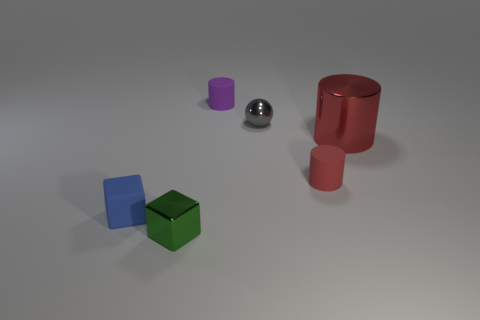Subtract all small matte cylinders. How many cylinders are left? 1 Subtract all brown spheres. How many red cylinders are left? 2 Add 2 shiny cylinders. How many objects exist? 8 Subtract all green cylinders. Subtract all gray spheres. How many cylinders are left? 3 Subtract 1 blue cubes. How many objects are left? 5 Subtract all cubes. How many objects are left? 4 Subtract all tiny gray matte things. Subtract all small red objects. How many objects are left? 5 Add 2 tiny red matte cylinders. How many tiny red matte cylinders are left? 3 Add 2 small red rubber objects. How many small red rubber objects exist? 3 